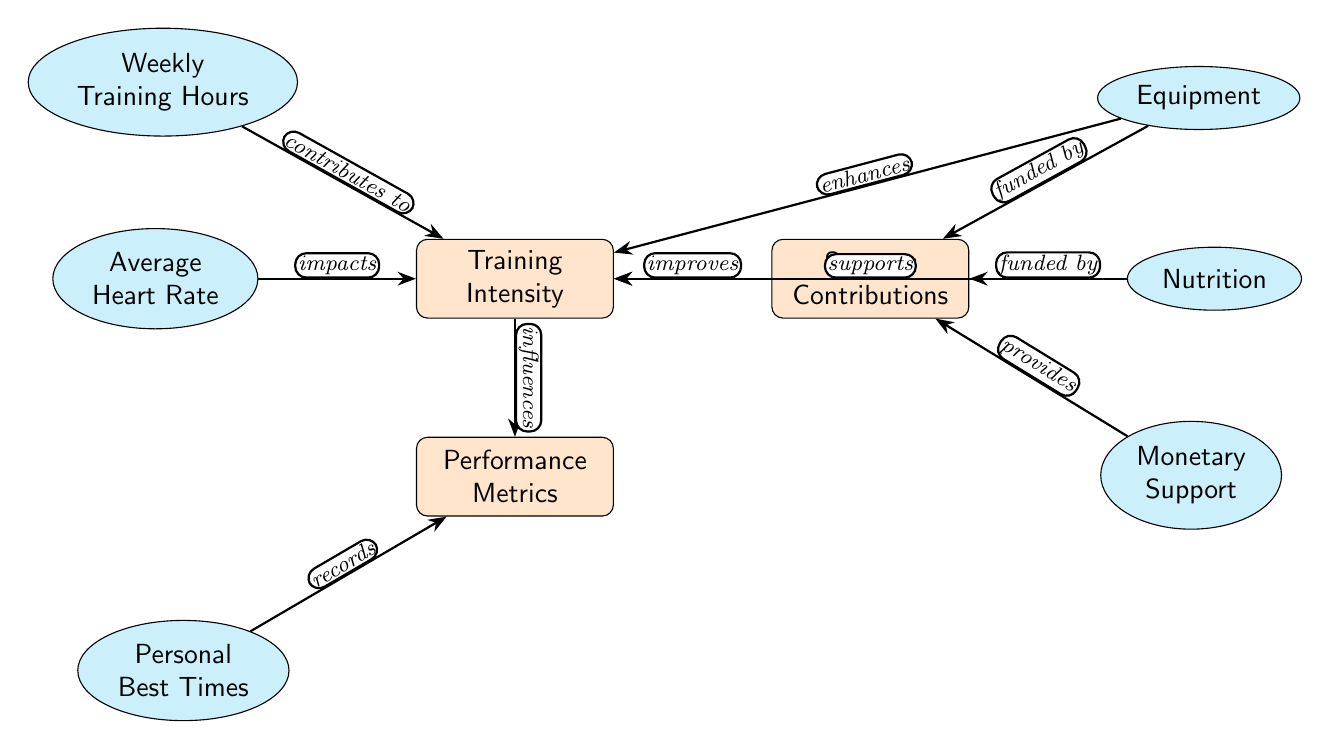What are the three main components in the diagram? The diagram contains three main components: Training Intensity, Performance Metrics, and Sponsor Contributions. These are clearly labeled as the main nodes in the center of the diagram.
Answer: Training Intensity, Performance Metrics, Sponsor Contributions How many sub-nodes are connected to the Training Intensity node? There are three sub-nodes connected to the Training Intensity node: Weekly Training Hours, Average Heart Rate, and Equipment. This can be confirmed by counting the sub-nodes directly connected to the Training Intensity node.
Answer: 3 What does "Average Heart Rate" do to "Training Intensity"? Average Heart Rate "impacts" Training Intensity, as indicated by the arrow and label connecting these two nodes in the diagram. This shows a direct influence relationship between Average Heart Rate and Training Intensity.
Answer: impacts Which component provides "Monetary Support"? "Sponsor Contributions" provides "Monetary Support," as indicated by the label showing that Monetary Support is one of the sub-nodes below Sponsor Contributions.
Answer: Sponsor Contributions What relationship exists between "Training Intensity" and "Performance Metrics"? Training Intensity "influences" Performance Metrics, which is shown by the directional arrow connecting these two nodes along with the label that describes their relationship.
Answer: influences What is connected to the "Performance Metrics" node? The "Performance Metrics" node is connected to "Personal Best Times," which records the outcomes of the Performance Metrics, as shown by the direct flow and labeled edge between these two nodes.
Answer: Personal Best Times Which element enhances "Training Intensity"? "Equipment" enhances Training Intensity, as depicted by the labeled edge that connects these two elements with the term "enhances," indicating that Equipment contributes positively to Training Intensity.
Answer: Equipment How many total nodes are present in the diagram? The diagram consists of a total of six nodes: three main nodes and three sub-nodes that are linked to the main components. By counting all nodes present—both main and sub—you can easily confirm this count.
Answer: 6 What funding sources support "Sponsor Contributions"? "Equipment" and "Nutrition" are the funding sources that support Sponsor Contributions, as indicated by the arrows labeled "funded by" that connect these elements to the Sponsor Contributions node.
Answer: Equipment, Nutrition 